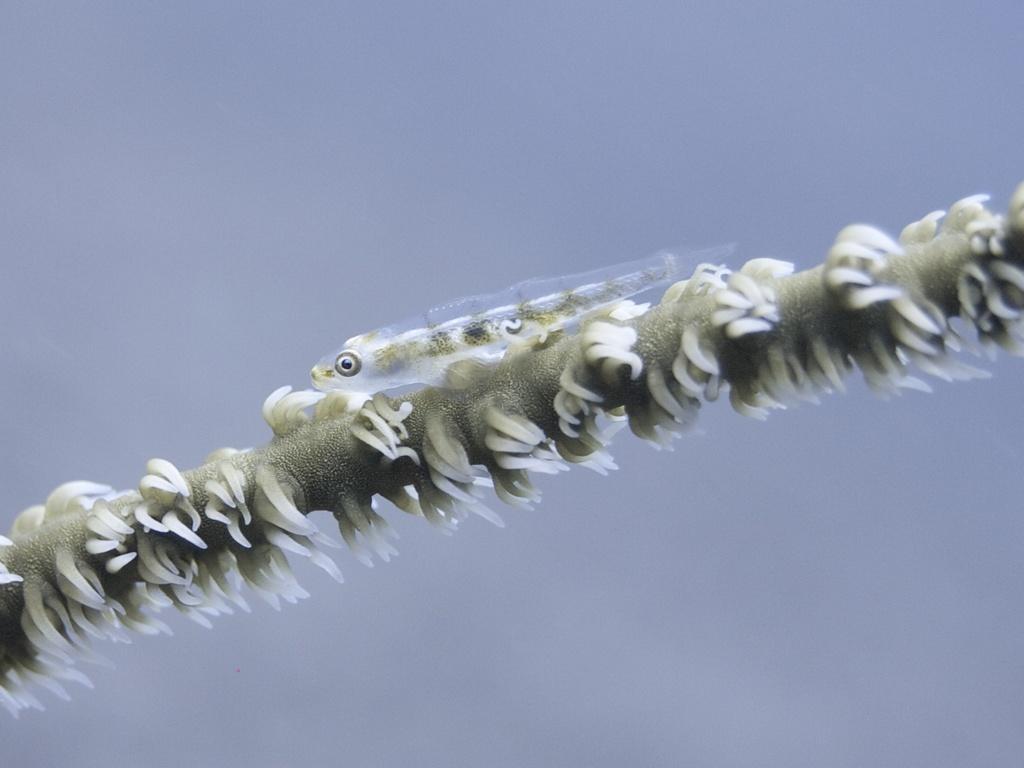Can you describe this image briefly? In this image there is a fish on the algae. 